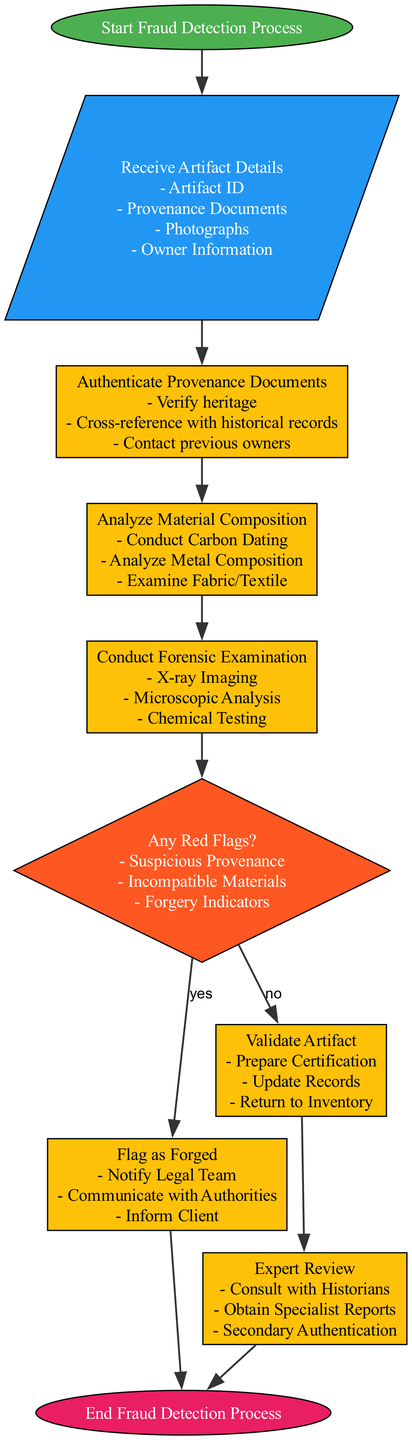What does the starting point of the diagram indicate? The starting point indicates the initiation of the fraud detection process, labeled as "Start Fraud Detection Process".
Answer: Start Fraud Detection Process How many elements are there in the diagram? There are a total of nine elements present in the diagram, including start, input, processes, decision, and end.
Answer: Nine What is the last step of the fraud detection process? The last step is labeled "End Fraud Detection Process", denoting the conclusion of the detection workflow.
Answer: End Fraud Detection Process What happens if red flags are identified during the process? If red flags are identified, the process moves to the "Flag as Forged" step, notifying the legal team and communicating with authorities.
Answer: Flag as Forged How is material analyzed in the fraud detection process? Material analysis involves conducting carbon dating, analyzing metal composition, and examining fabric or textile of the artifact.
Answer: Analyze Material Composition What occurs right after the forensic examination? Right after the forensic examination, a decision is made about whether there are any red flags in the artifact’s authentication process.
Answer: Flag Check What determines the flow to the expert review process? The flow to the expert review process is determined by the decision node "Any Red Flags?", specifically if the answer is "no" indicating the artifact is not flagged as forged.
Answer: No List the tasks involved in the authentication of provenance documents. The tasks include verifying heritage, cross-referencing with historical records, and contacting previous owners of the artifact.
Answer: Verify heritage, cross-reference with historical records, contact previous owners What is the function of the decision node in the diagram? The function of the decision node is to assess whether there are any red flags present that may indicate suspicious activity regarding the artifact.
Answer: Any Red Flags? 